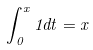Convert formula to latex. <formula><loc_0><loc_0><loc_500><loc_500>\int _ { 0 } ^ { x } 1 d t = x</formula> 